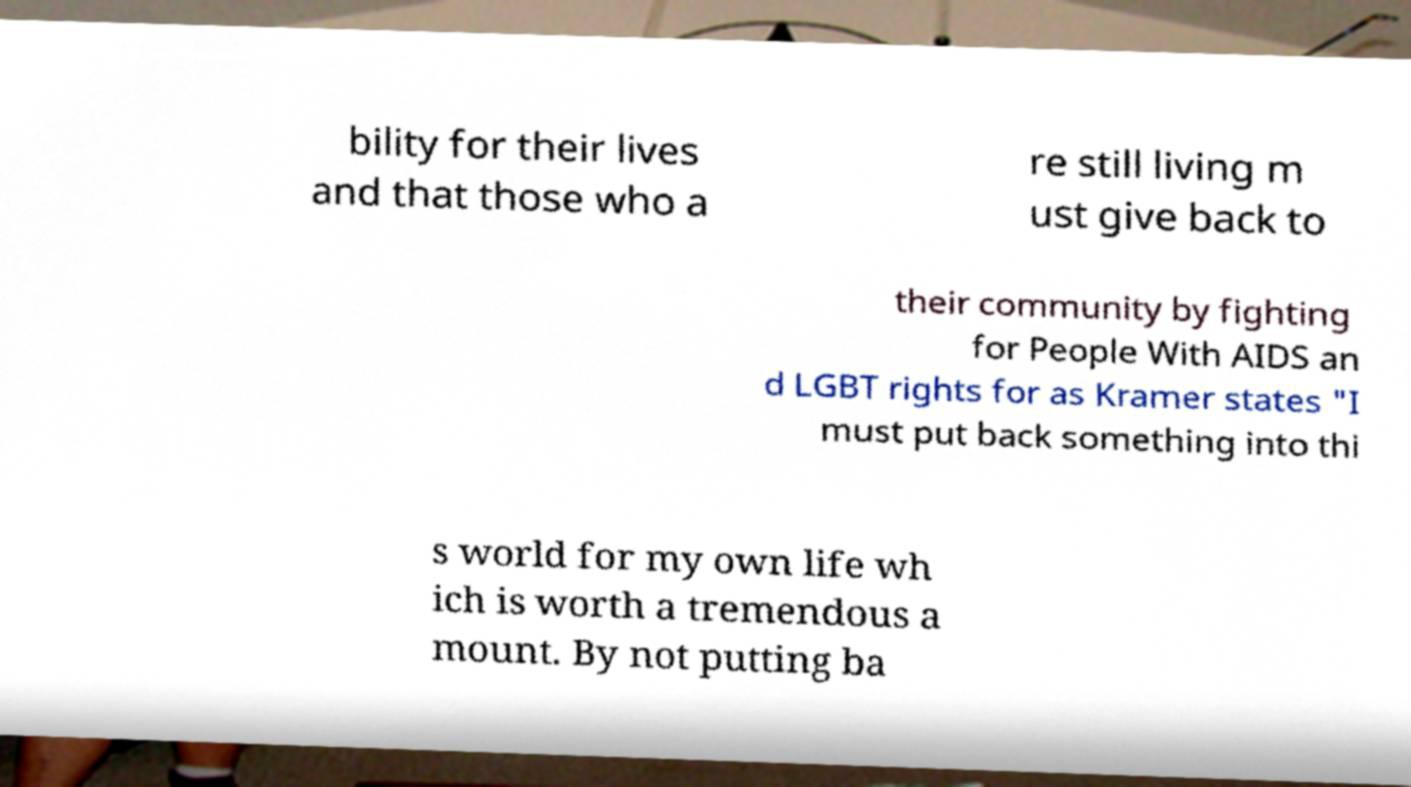I need the written content from this picture converted into text. Can you do that? bility for their lives and that those who a re still living m ust give back to their community by fighting for People With AIDS an d LGBT rights for as Kramer states "I must put back something into thi s world for my own life wh ich is worth a tremendous a mount. By not putting ba 